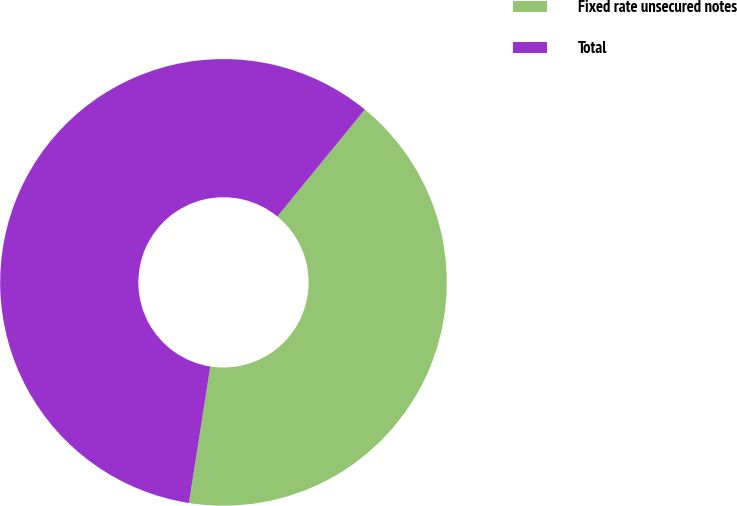<chart> <loc_0><loc_0><loc_500><loc_500><pie_chart><fcel>Fixed rate unsecured notes<fcel>Total<nl><fcel>41.56%<fcel>58.44%<nl></chart> 